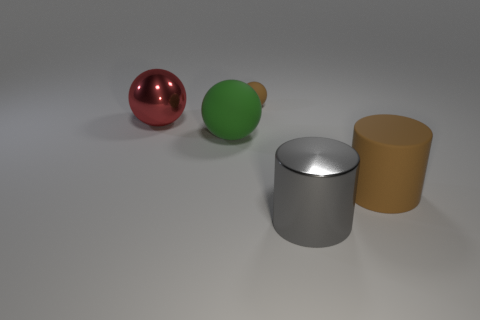Add 1 large purple rubber spheres. How many objects exist? 6 Subtract all tiny brown rubber spheres. How many spheres are left? 2 Subtract all spheres. How many objects are left? 2 Subtract 1 cylinders. How many cylinders are left? 1 Subtract all green balls. Subtract all cyan cylinders. How many balls are left? 2 Subtract all green cylinders. How many red balls are left? 1 Subtract all purple cubes. Subtract all cylinders. How many objects are left? 3 Add 3 big shiny objects. How many big shiny objects are left? 5 Add 2 large green balls. How many large green balls exist? 3 Subtract all red spheres. How many spheres are left? 2 